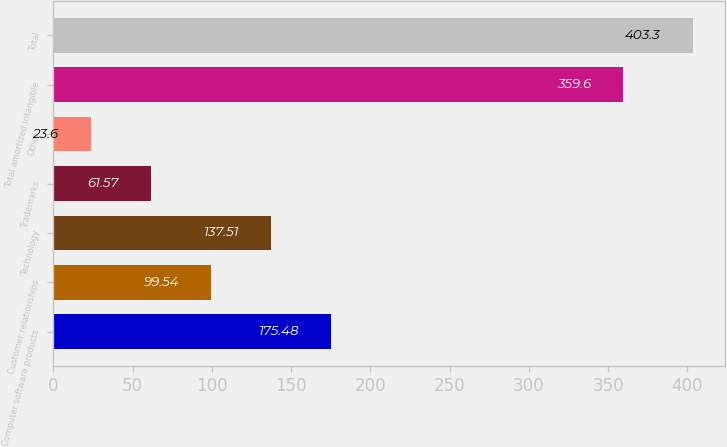Convert chart to OTSL. <chart><loc_0><loc_0><loc_500><loc_500><bar_chart><fcel>Computer software products<fcel>Customer relationships<fcel>Technology<fcel>Trademarks<fcel>Other<fcel>Total amortized intangible<fcel>Total<nl><fcel>175.48<fcel>99.54<fcel>137.51<fcel>61.57<fcel>23.6<fcel>359.6<fcel>403.3<nl></chart> 